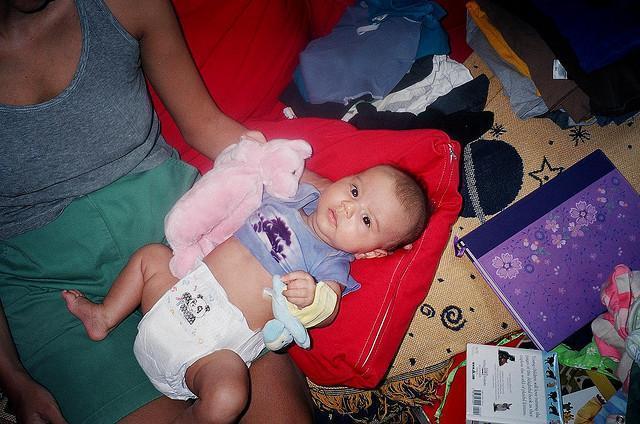How many beds can you see?
Give a very brief answer. 1. How many people are in the photo?
Give a very brief answer. 2. How many of the frisbees are in the air?
Give a very brief answer. 0. 